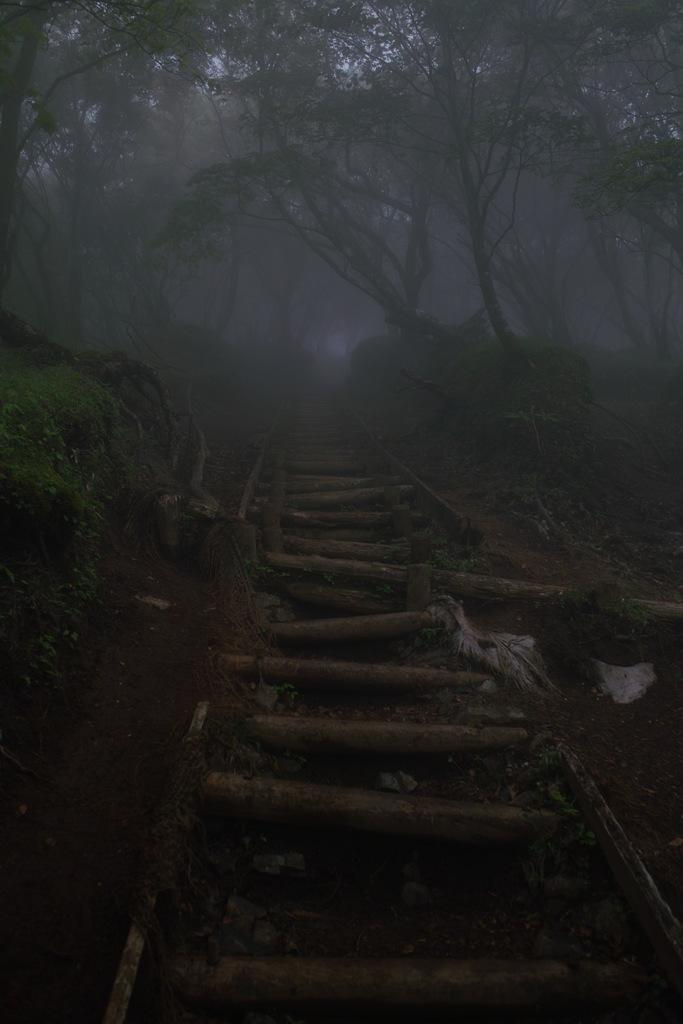What type of vegetation can be seen in the image? There is grass, plants, and trees in the image. Can you describe the natural environment depicted in the image? The image features a variety of vegetation, including grass, plants, and trees. What type of lace can be seen on the trees in the image? There is no lace present on the trees in the image; it is a natural environment with vegetation. 